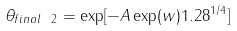Convert formula to latex. <formula><loc_0><loc_0><loc_500><loc_500>\theta _ { f i n a l \ 2 } = \exp [ - A \exp ( w ) 1 . 2 8 ^ { 1 / 4 } ] \ \</formula> 